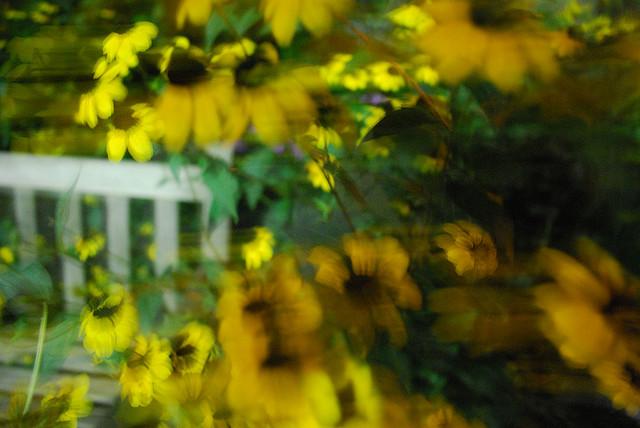Why is the picture blurry?
Quick response, please. Camera moved. What type of flower is this?
Give a very brief answer. Sunflower. Is the flowers in a vase?
Give a very brief answer. No. What color are the flowers?
Short answer required. Yellow. What type of flower is in the picture?
Concise answer only. Sunflower. 